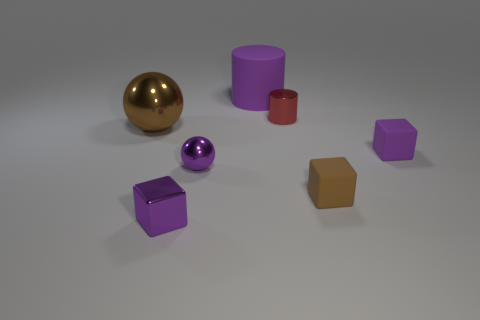How many objects are there and can you describe their shapes? In the image, there are seven objects. Starting from the left, there's a shiny gold sphere, a large matte purple cylinder, a smaller glossy purple sphere, a small matte red cylinder, a matte brown hexagonal prism, and two matte purple cubes of different sizes. Which object appears to be the smallest? The smallest object in the image looks to be the small red cylinder. 